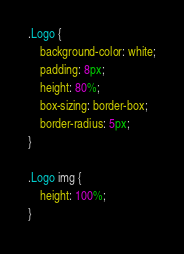<code> <loc_0><loc_0><loc_500><loc_500><_CSS_>.Logo {
    background-color: white;
    padding: 8px;
    height: 80%;
    box-sizing: border-box;
    border-radius: 5px;
}

.Logo img {
    height: 100%;
}</code> 